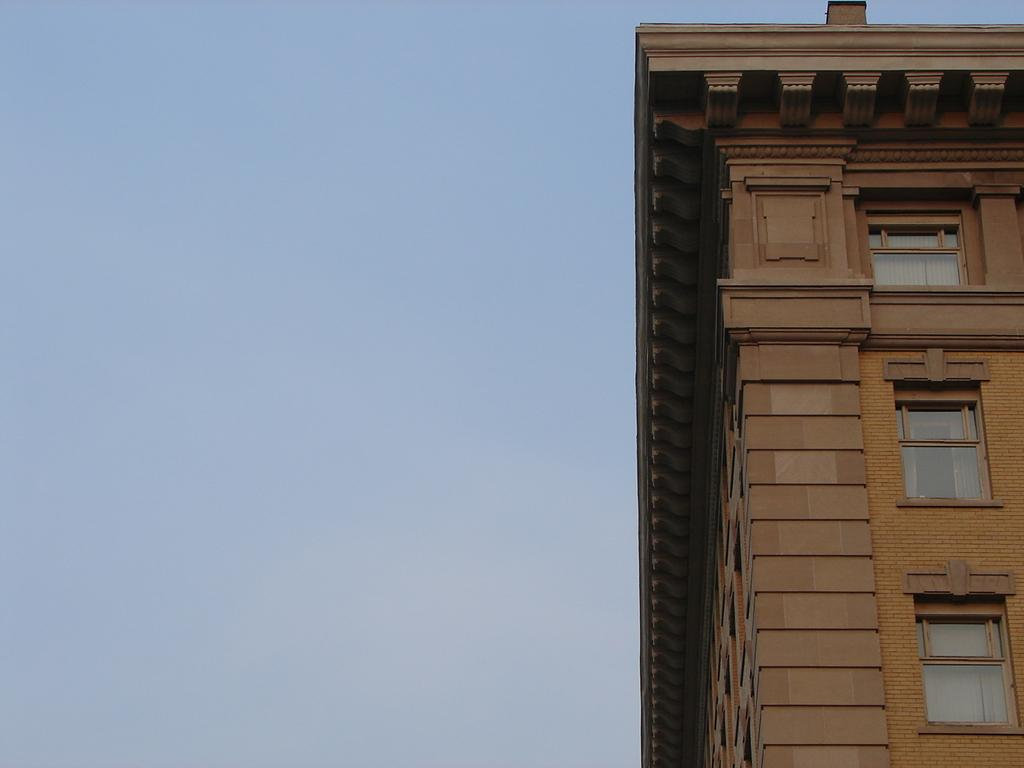What is the main subject of the picture? The main subject of the picture is a building. What specific features can be seen on the building? The building has windows. What can be seen in the background of the picture? The sky is visible behind the building. What type of floor is visible in the picture? There is no floor visible in the picture, as it only features a building and the sky in the background. What account is associated with the building in the picture? There is no account mentioned or associated with the building in the picture. 